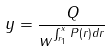<formula> <loc_0><loc_0><loc_500><loc_500>y = \frac { Q } { w ^ { \int _ { r _ { 1 } } ^ { x } P ( r ) d r } }</formula> 